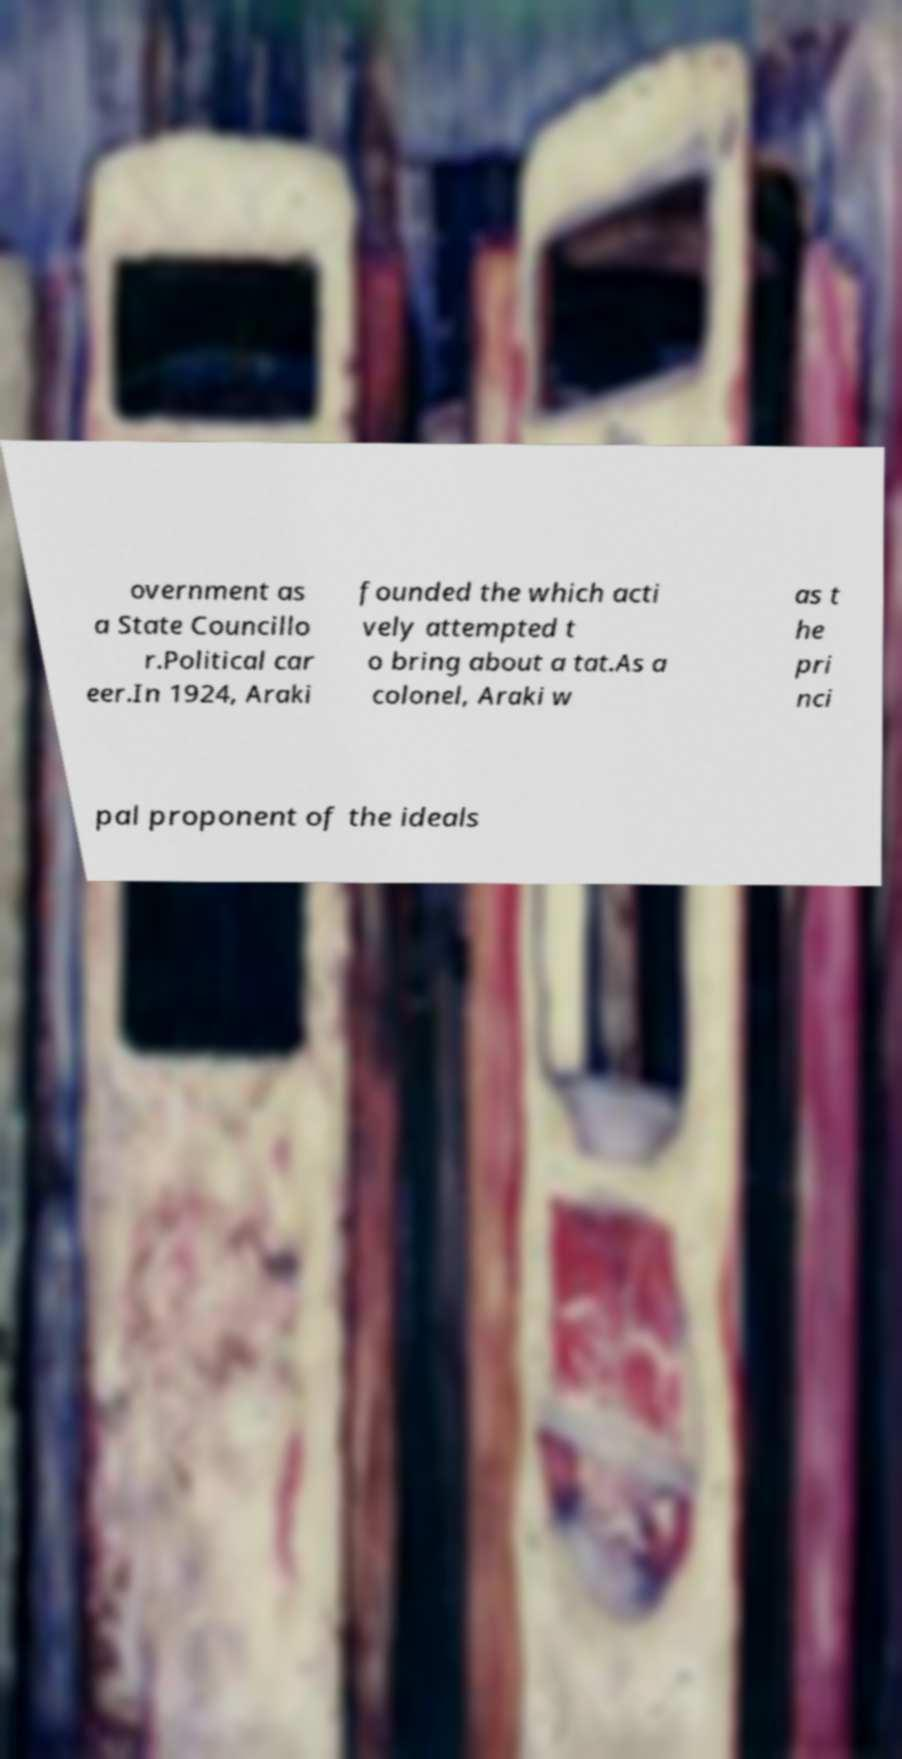What messages or text are displayed in this image? I need them in a readable, typed format. overnment as a State Councillo r.Political car eer.In 1924, Araki founded the which acti vely attempted t o bring about a tat.As a colonel, Araki w as t he pri nci pal proponent of the ideals 